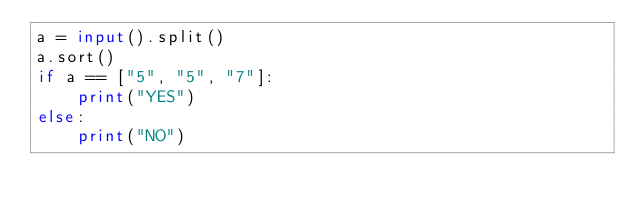Convert code to text. <code><loc_0><loc_0><loc_500><loc_500><_Python_>a = input().split()
a.sort()
if a == ["5", "5", "7"]:
    print("YES")
else:
    print("NO")</code> 